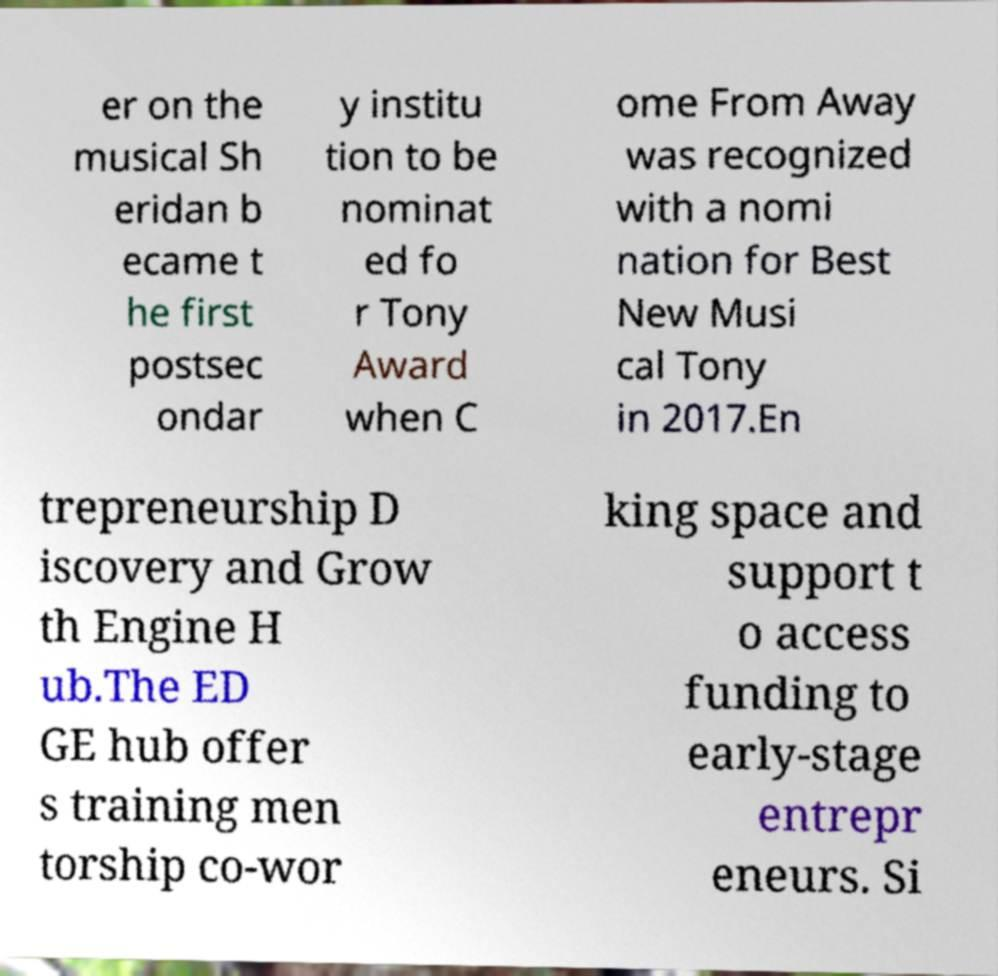What messages or text are displayed in this image? I need them in a readable, typed format. er on the musical Sh eridan b ecame t he first postsec ondar y institu tion to be nominat ed fo r Tony Award when C ome From Away was recognized with a nomi nation for Best New Musi cal Tony in 2017.En trepreneurship D iscovery and Grow th Engine H ub.The ED GE hub offer s training men torship co-wor king space and support t o access funding to early-stage entrepr eneurs. Si 